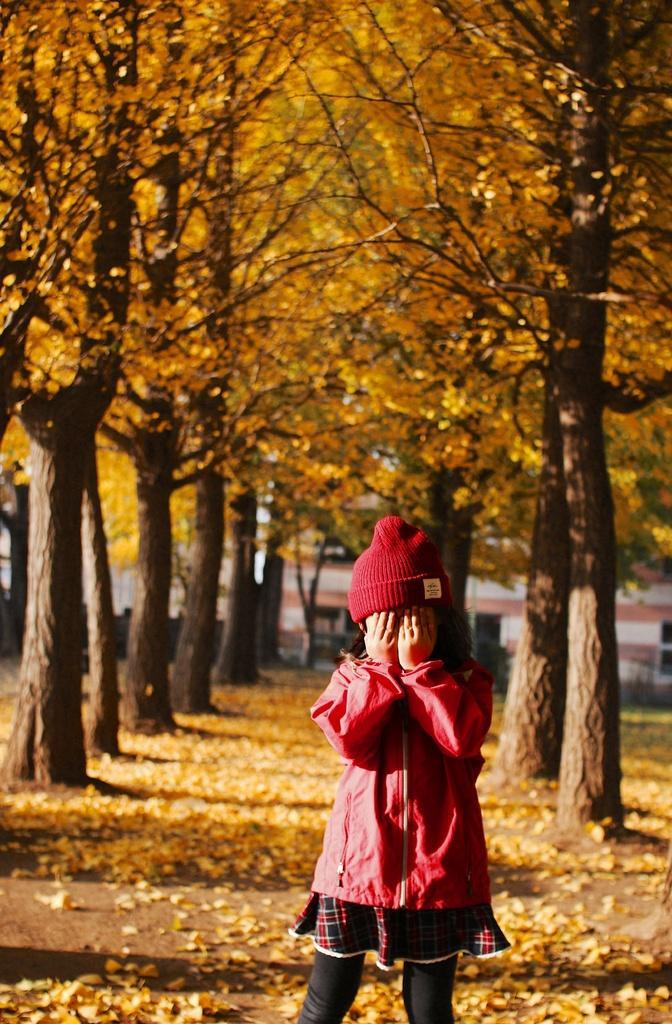Describe this image in one or two sentences. In this image we can see a girl standing, behind her we can see some trees and leaves on the ground, in the background we can see a building. 